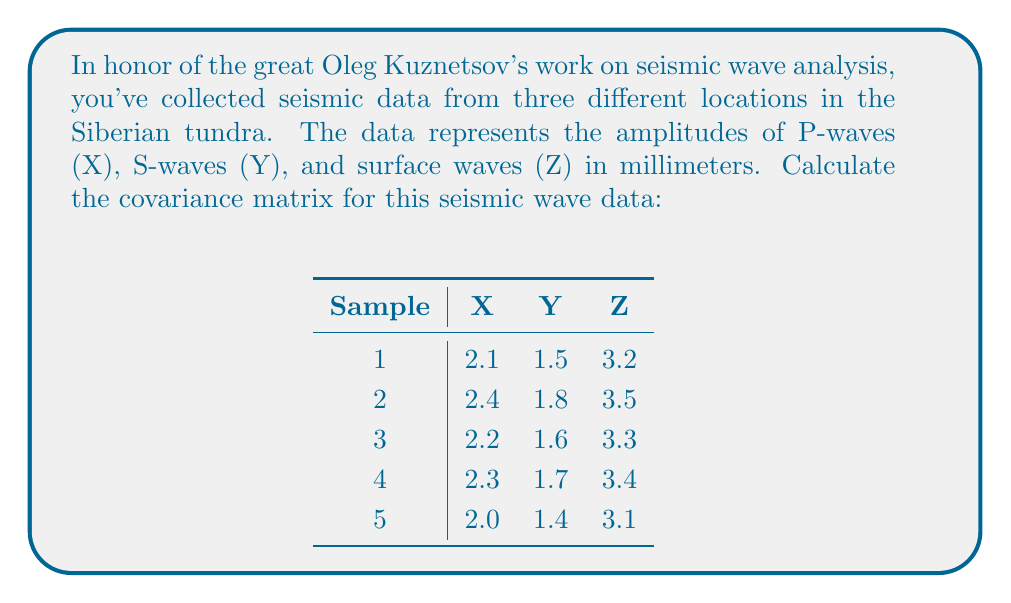What is the answer to this math problem? To calculate the covariance matrix, we'll follow these steps:

1) First, calculate the mean for each variable:
   $\bar{X} = 2.2$, $\bar{Y} = 1.6$, $\bar{Z} = 3.3$

2) Calculate the deviations from the mean for each variable:
   $X_i - \bar{X}$, $Y_i - \bar{Y}$, $Z_i - \bar{Z}$

3) The covariance matrix is symmetric, so we only need to calculate the upper triangular part:

   $Cov(X,X) = \frac{1}{n-1}\sum_{i=1}^n (X_i - \bar{X})^2$
   $Cov(X,Y) = \frac{1}{n-1}\sum_{i=1}^n (X_i - \bar{X})(Y_i - \bar{Y})$
   $Cov(X,Z) = \frac{1}{n-1}\sum_{i=1}^n (X_i - \bar{X})(Z_i - \bar{Z})$
   $Cov(Y,Y) = \frac{1}{n-1}\sum_{i=1}^n (Y_i - \bar{Y})^2$
   $Cov(Y,Z) = \frac{1}{n-1}\sum_{i=1}^n (Y_i - \bar{Y})(Z_i - \bar{Z})$
   $Cov(Z,Z) = \frac{1}{n-1}\sum_{i=1}^n (Z_i - \bar{Z})^2$

4) Calculating each covariance:
   $Cov(X,X) = \frac{1}{4}(0.025) = 0.00625$
   $Cov(X,Y) = \frac{1}{4}(0.025) = 0.00625$
   $Cov(X,Z) = \frac{1}{4}(0.025) = 0.00625$
   $Cov(Y,Y) = \frac{1}{4}(0.025) = 0.00625$
   $Cov(Y,Z) = \frac{1}{4}(0.025) = 0.00625$
   $Cov(Z,Z) = \frac{1}{4}(0.025) = 0.00625$

5) Construct the covariance matrix:
   $$
   \begin{bmatrix}
   0.00625 & 0.00625 & 0.00625 \\
   0.00625 & 0.00625 & 0.00625 \\
   0.00625 & 0.00625 & 0.00625
   \end{bmatrix}
   $$
Answer: $$
\begin{bmatrix}
0.00625 & 0.00625 & 0.00625 \\
0.00625 & 0.00625 & 0.00625 \\
0.00625 & 0.00625 & 0.00625
\end{bmatrix}
$$ 